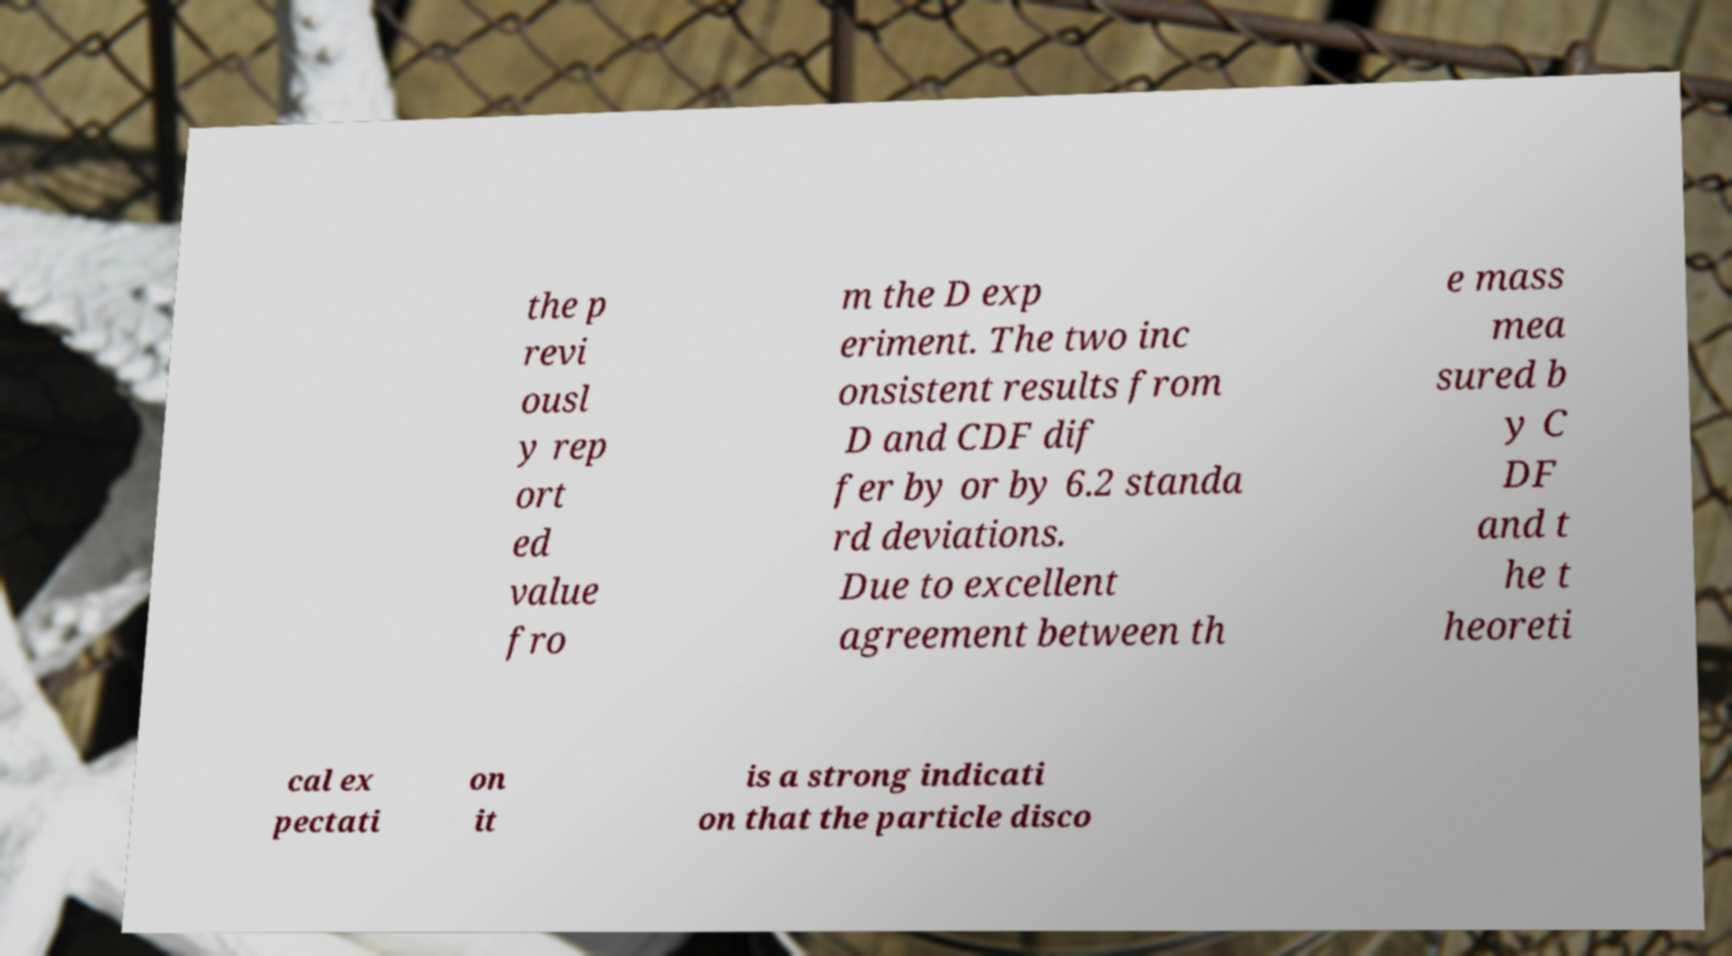There's text embedded in this image that I need extracted. Can you transcribe it verbatim? the p revi ousl y rep ort ed value fro m the D exp eriment. The two inc onsistent results from D and CDF dif fer by or by 6.2 standa rd deviations. Due to excellent agreement between th e mass mea sured b y C DF and t he t heoreti cal ex pectati on it is a strong indicati on that the particle disco 